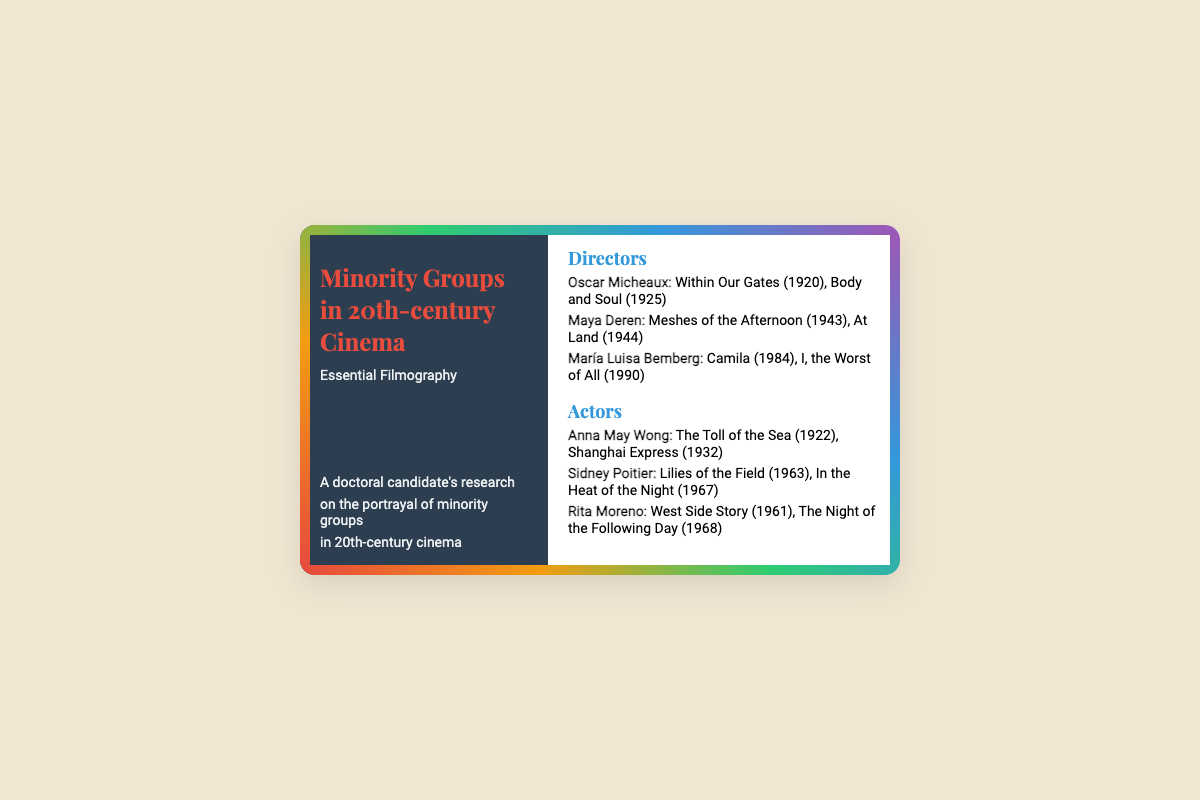What is the title of the first film by Oscar Micheaux? Oscar Micheaux's first film listed is "Within Our Gates" from 1920.
Answer: Within Our Gates Who directed "Meshes of the Afternoon"? "Meshes of the Afternoon" was directed by Maya Deren in 1943.
Answer: Maya Deren What year was "Camila" released? "Camila" was released in 1984, as stated in María Luisa Bemberg's filmography.
Answer: 1984 Which actor starred in "West Side Story"? The actor who starred in "West Side Story" is Rita Moreno.
Answer: Rita Moreno How many films are listed for Sidney Poitier? Two films are listed for Sidney Poitier: "Lilies of the Field" and "In the Heat of the Night".
Answer: Two What color is the left side of the business card? The left side of the business card is colored dark blue, specifically #2c3e50.
Answer: Dark blue Which director is associated with the film "Body and Soul"? "Body and Soul" is associated with director Oscar Micheaux.
Answer: Oscar Micheaux What is the main focus of the research mentioned on the card? The research focuses on the portrayal of minority groups in 20th-century cinema.
Answer: Portrayal of minority groups Which section contains filmography of directors? The section titled "Directors" contains their filmography.
Answer: Directors 